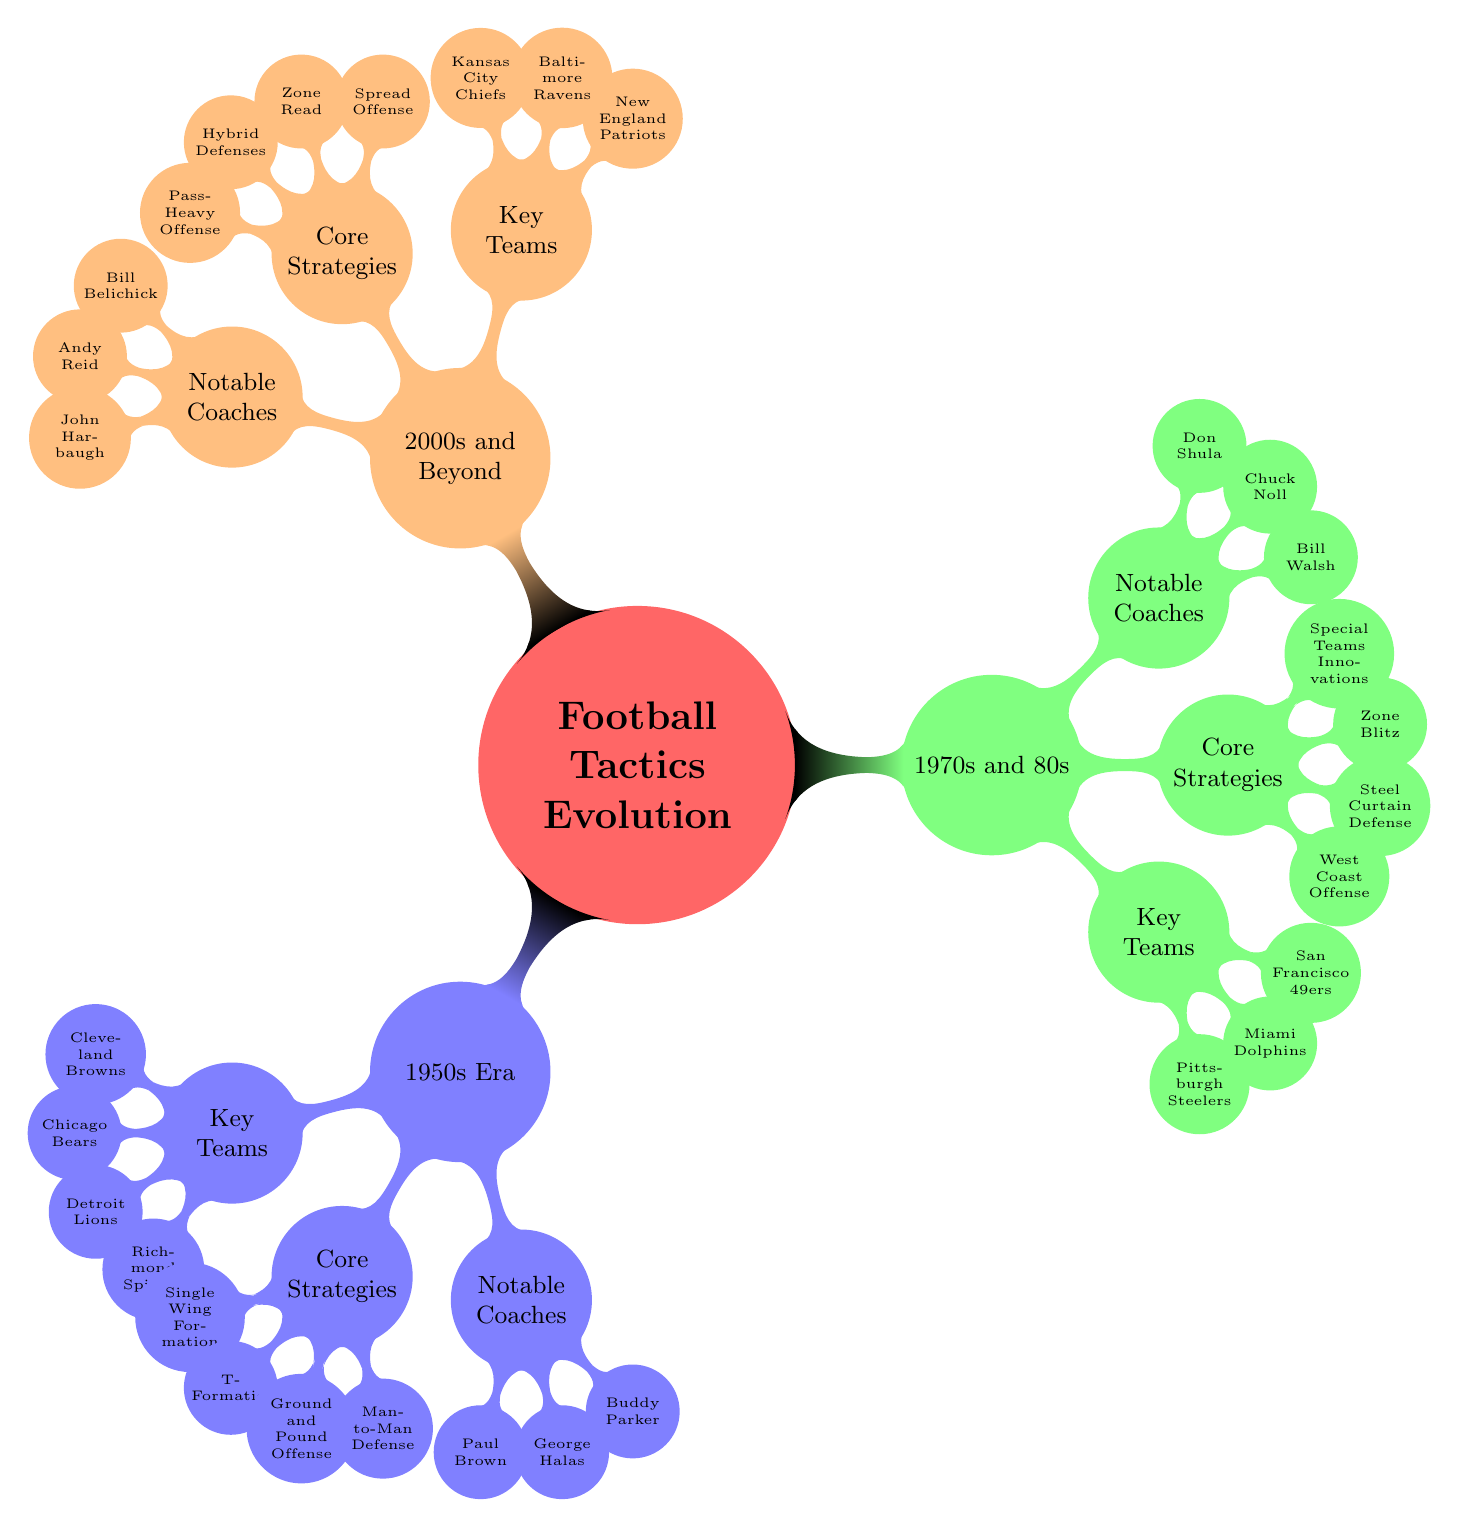What are the key teams in the 1950s Era? The diagram provides a node labeled "Key Teams" under the "1950s Era," which lists the teams: Cleveland Browns, Chicago Bears, Detroit Lions, and Richmond Spiders.
Answer: Cleveland Browns, Chicago Bears, Detroit Lions, Richmond Spiders How many core strategies are listed for the 1970s and 80s? The node labeled "Core Strategies" under the "1970s and 80s" section contains four strategies: West Coast Offense, Steel Curtain Defense, Zone Blitz, and Special Teams Innovations. Therefore, there are a total of four strategies listed.
Answer: 4 Which notable coach is associated with the 2000s and Beyond? The diagram shows the "Notable Coaches" node under "2000s and Beyond," listing Bill Belichick, Andy Reid, and John Harbaugh. Any of these names would be correct, but one specific notable coach can be identified.
Answer: Bill Belichick What strategy is unique to the 1950s Era? The node "Core Strategies" under the "1950s Era" includes strategies that are specific to that time, such as Single Wing Formation, T-Formation, Ground and Pound Offense, and Man-to-Man Defense. One unique strategy identifiable here is "Single Wing Formation."
Answer: Single Wing Formation Which team is mentioned under both the 1950s Era and notable coaches? In the "1950s Era," there is no node listing teams’ associations with coaches. However, notable coaches like Paul Brown are indirectly related due to the context of their time. Yet, no particular team is mentioned under notable coaches that matches with the teams in the 1950s. Thus, this is a reasoning-based question.
Answer: No specific team What is a common feature of the strategies from the 2000s and Beyond? The "Core Strategies" listed under "2000s and Beyond" include Spread Offense, Zone Read, Hybrid Defenses, and Pass-Heavy Offense. A common feature among these modern strategies is a focus on offensive versatility and adapting to current trends in football, particularly emphasizing passing strategies.
Answer: Pass-Heavy Offense Which decade introduced the West Coast Offense? The "Core Strategies" node under the "1970s and 80s" clearly points out that the West Coast Offense is a strategy from that period, making it associated with the 1970s and 80s era.
Answer: 1970s and 80s How do the coaching legends differ across eras? By observing the nodes labeled "Notable Coaches," under each era—Paul Brown, George Halas, and Buddy Parker in the 1950s; Bill Walsh, Chuck Noll, and Don Shula in the 1970s and 80s; and Bill Belichick, Andy Reid, and John Harbaugh in 2000s and Beyond—we can see a progression in coaching styles reflecting their respective eras' tactical evolution. Therefore, coaches adapt their strategies according to the football dynamics and styles prevalent at their time.
Answer: Different coaching styles across eras 